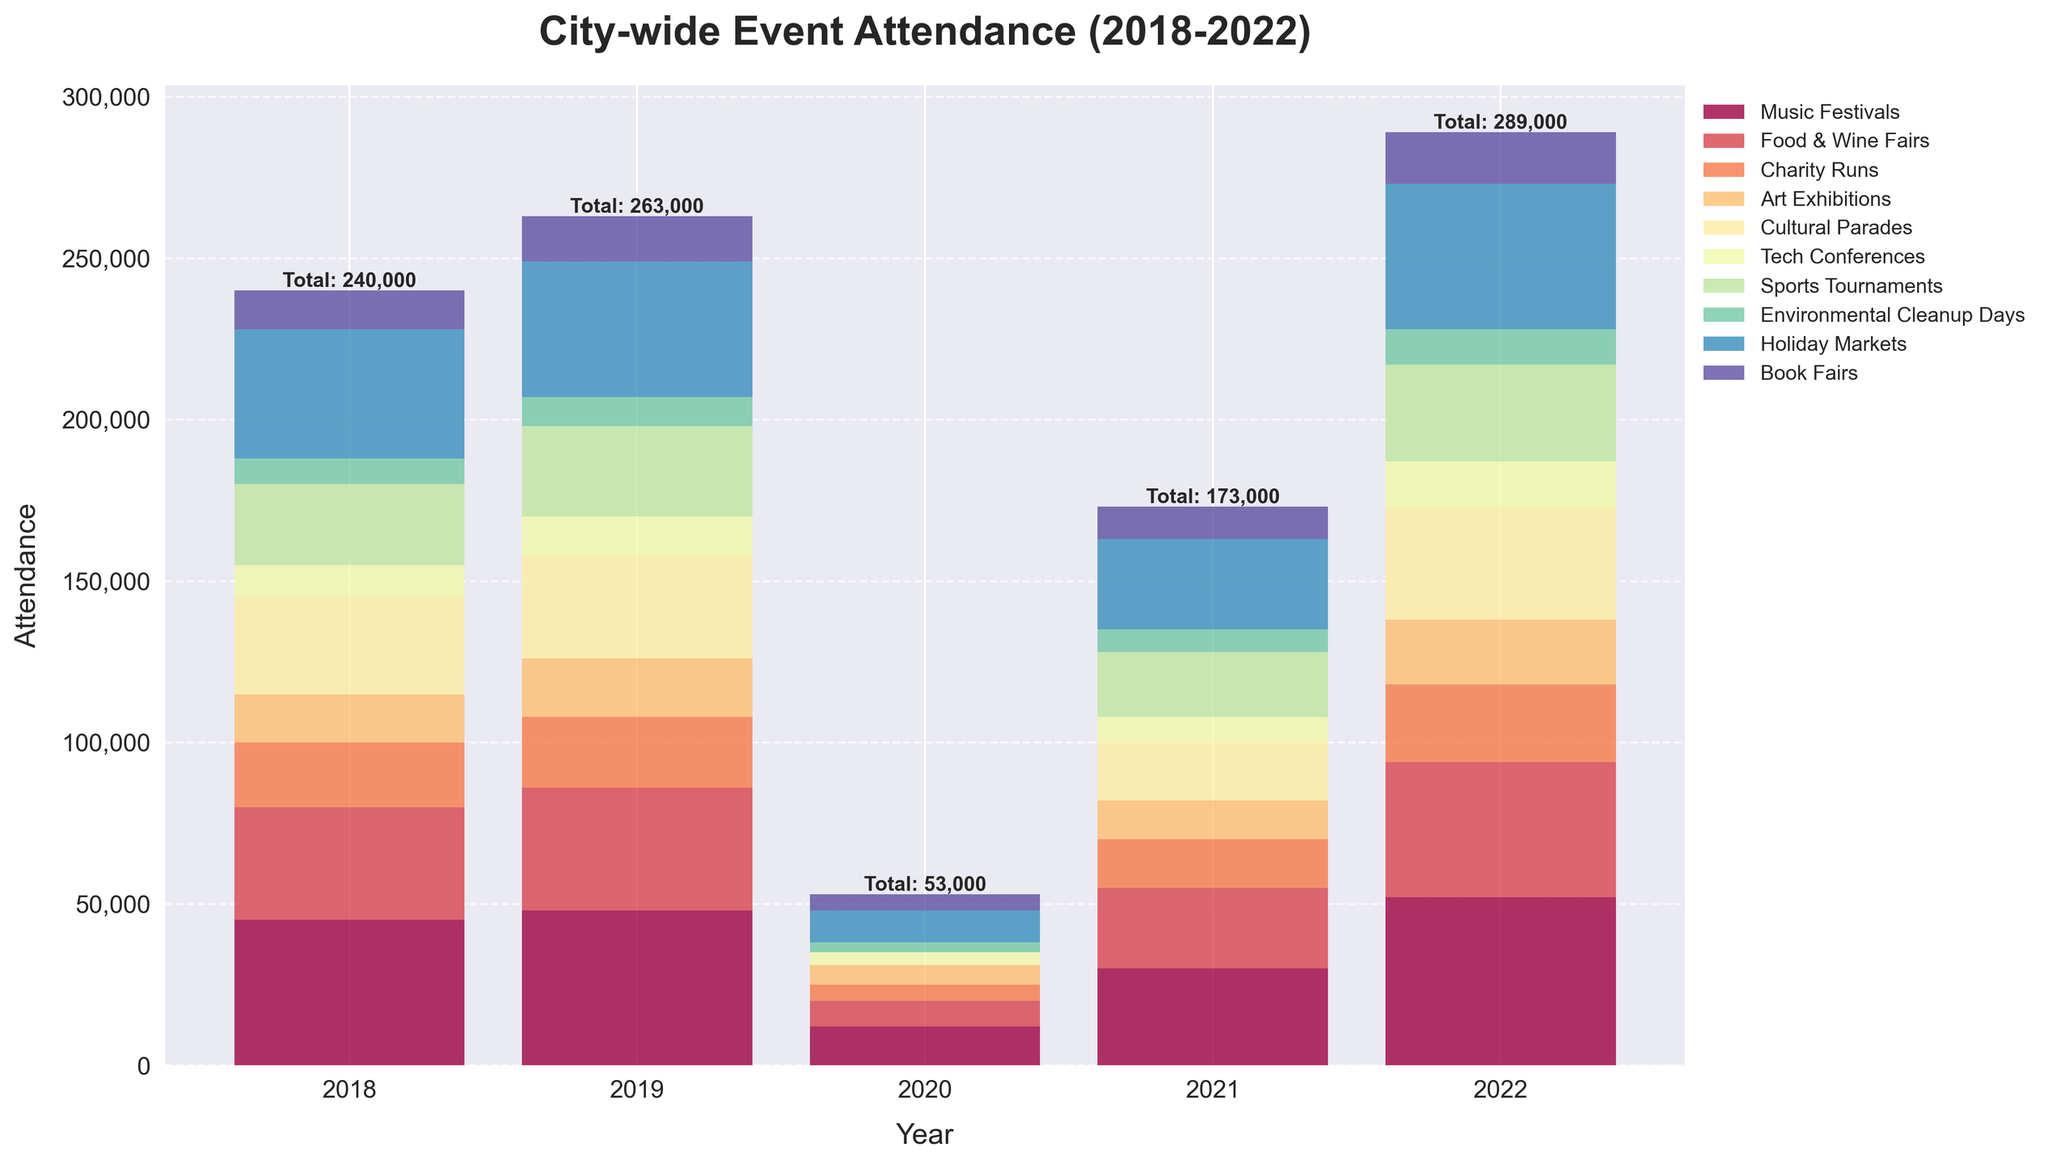Which event type had the highest attendance in 2022? Look at the heights of the bars for each event type in 2022. The tallest bar represents the highest attendance. For 2022, Music Festivals has the highest attendance.
Answer: Music Festivals What was the total attendance for all events in 2020? To find the total attendance in 2020, sum all the heights of the bars for that year. Music Festivals: 12,000 + Food & Wine Fairs: 8,000 + Charity Runs: 5,000 + Art Exhibitions: 6,000 + Cultural Parades: 0 + Tech Conferences: 4,000 + Sports Tournaments: 0 + Environmental Cleanup Days: 3,000 + Holiday Markets: 10,000 + Book Fairs: 5,000. Total: 53,000.
Answer: 53,000 Which event type showed the largest increase in attendance from 2021 to 2022? Subtract the 2021 value from the 2022 value for each event type and find the largest positive difference. Music Festivals: 52,000 - 30,000 = 22,000, Food & Wine Fairs: 42,000 - 25,000 = 17,000, Charity Runs: 24,000 - 15,000 = 9,000, Art Exhibitions: 20,000 - 12,000 = 8,000, Cultural Parades: 35,000 - 18,000 = 17,000, Tech Conferences: 14,000 - 8,000 = 6,000, Sports Tournaments: 30,000 - 20,000 = 10,000, Environmental Cleanup Days: 11,000 - 7,000 = 4,000, Holiday Markets: 45,000 - 28,000 = 17,000, Book Fairs: 16,000 - 10,000 = 6,000. The largest increase of 22,000 is for Music Festivals.
Answer: Music Festivals Which years had a total attendance of over 200,000 people for all events combined? Sum the total attendance for each year and check which are over 200,000. 2018: 234,000, 2019: 269,000, 2020: 53,000, 2021: 135,000, 2022: 265,000. The years 2018, 2019, and 2022 all had over 200,000 total attendance.
Answer: 2018, 2019, 2022 In which year did Cultural Parades have the lowest attendance? Check the heights of the bars for Cultural Parades for each year. The lowest value (excluding 'Canceled') is in its smallest bar. Cultural Parades have their lowest attendance in 2021 with 18,000.
Answer: 2021 Which event type had the most stable attendance (least variation) over the 5 years? Calculate the range (max - min) of attendance for each event type from 2018 to 2022. The smallest range indicates the most stable attendance. Music Festivals: 52,000 - 12,000 = 40,000, Food & Wine Fairs: 42,000 - 8,000 = 34,000, Charity Runs: 24,000 - 5,000 = 19,000, Art Exhibitions: 20,000 - 6,000 = 14,000, Cultural Parades: 35,000 - 0 (Canceled) = 35,000, Tech Conferences: 14,000 - 4,000 = 10,000, Sports Tournaments: 30,000 - 0 (Canceled) = 30,000, Environmental Cleanup Days: 11,000 - 3,000 = 8,000, Holiday Markets: 45,000 - 10,000 = 35,000, Book Fairs: 16,000 - 5,000 = 11,000. The range is smallest for Environmental Cleanup Days with a variation of 8,000.
Answer: Environmental Cleanup Days 